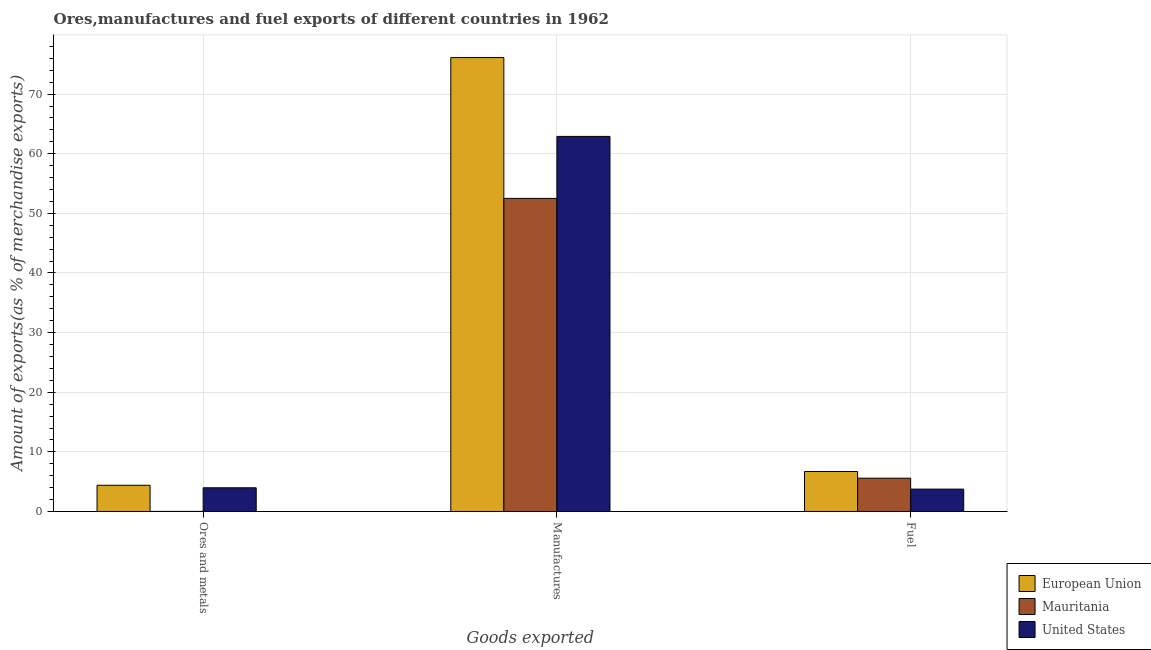How many different coloured bars are there?
Give a very brief answer. 3. How many groups of bars are there?
Make the answer very short. 3. Are the number of bars on each tick of the X-axis equal?
Your answer should be compact. Yes. What is the label of the 1st group of bars from the left?
Provide a succinct answer. Ores and metals. What is the percentage of manufactures exports in European Union?
Your answer should be very brief. 76.13. Across all countries, what is the maximum percentage of fuel exports?
Give a very brief answer. 6.71. Across all countries, what is the minimum percentage of fuel exports?
Your answer should be compact. 3.75. What is the total percentage of manufactures exports in the graph?
Offer a very short reply. 191.56. What is the difference between the percentage of manufactures exports in United States and that in European Union?
Ensure brevity in your answer.  -13.22. What is the difference between the percentage of fuel exports in European Union and the percentage of manufactures exports in United States?
Offer a very short reply. -56.21. What is the average percentage of ores and metals exports per country?
Provide a succinct answer. 2.79. What is the difference between the percentage of fuel exports and percentage of manufactures exports in European Union?
Ensure brevity in your answer.  -69.43. What is the ratio of the percentage of ores and metals exports in European Union to that in United States?
Give a very brief answer. 1.11. Is the difference between the percentage of manufactures exports in Mauritania and United States greater than the difference between the percentage of ores and metals exports in Mauritania and United States?
Make the answer very short. No. What is the difference between the highest and the second highest percentage of ores and metals exports?
Give a very brief answer. 0.42. What is the difference between the highest and the lowest percentage of fuel exports?
Offer a terse response. 2.95. Is the sum of the percentage of fuel exports in European Union and United States greater than the maximum percentage of manufactures exports across all countries?
Offer a terse response. No. Is it the case that in every country, the sum of the percentage of ores and metals exports and percentage of manufactures exports is greater than the percentage of fuel exports?
Offer a terse response. Yes. How many bars are there?
Provide a short and direct response. 9. How many countries are there in the graph?
Give a very brief answer. 3. Are the values on the major ticks of Y-axis written in scientific E-notation?
Make the answer very short. No. Where does the legend appear in the graph?
Offer a very short reply. Bottom right. What is the title of the graph?
Your answer should be compact. Ores,manufactures and fuel exports of different countries in 1962. What is the label or title of the X-axis?
Your answer should be very brief. Goods exported. What is the label or title of the Y-axis?
Ensure brevity in your answer.  Amount of exports(as % of merchandise exports). What is the Amount of exports(as % of merchandise exports) of European Union in Ores and metals?
Ensure brevity in your answer.  4.4. What is the Amount of exports(as % of merchandise exports) in Mauritania in Ores and metals?
Offer a terse response. 0.01. What is the Amount of exports(as % of merchandise exports) of United States in Ores and metals?
Ensure brevity in your answer.  3.97. What is the Amount of exports(as % of merchandise exports) in European Union in Manufactures?
Your answer should be very brief. 76.13. What is the Amount of exports(as % of merchandise exports) of Mauritania in Manufactures?
Offer a very short reply. 52.51. What is the Amount of exports(as % of merchandise exports) in United States in Manufactures?
Provide a short and direct response. 62.91. What is the Amount of exports(as % of merchandise exports) of European Union in Fuel?
Offer a terse response. 6.71. What is the Amount of exports(as % of merchandise exports) of Mauritania in Fuel?
Your answer should be very brief. 5.58. What is the Amount of exports(as % of merchandise exports) of United States in Fuel?
Your answer should be compact. 3.75. Across all Goods exported, what is the maximum Amount of exports(as % of merchandise exports) of European Union?
Your response must be concise. 76.13. Across all Goods exported, what is the maximum Amount of exports(as % of merchandise exports) of Mauritania?
Give a very brief answer. 52.51. Across all Goods exported, what is the maximum Amount of exports(as % of merchandise exports) in United States?
Your answer should be compact. 62.91. Across all Goods exported, what is the minimum Amount of exports(as % of merchandise exports) in European Union?
Your answer should be very brief. 4.4. Across all Goods exported, what is the minimum Amount of exports(as % of merchandise exports) of Mauritania?
Offer a terse response. 0.01. Across all Goods exported, what is the minimum Amount of exports(as % of merchandise exports) of United States?
Offer a very short reply. 3.75. What is the total Amount of exports(as % of merchandise exports) in European Union in the graph?
Provide a short and direct response. 87.24. What is the total Amount of exports(as % of merchandise exports) in Mauritania in the graph?
Your answer should be very brief. 58.11. What is the total Amount of exports(as % of merchandise exports) in United States in the graph?
Your response must be concise. 70.64. What is the difference between the Amount of exports(as % of merchandise exports) in European Union in Ores and metals and that in Manufactures?
Your answer should be compact. -71.74. What is the difference between the Amount of exports(as % of merchandise exports) in Mauritania in Ores and metals and that in Manufactures?
Keep it short and to the point. -52.5. What is the difference between the Amount of exports(as % of merchandise exports) of United States in Ores and metals and that in Manufactures?
Provide a short and direct response. -58.94. What is the difference between the Amount of exports(as % of merchandise exports) in European Union in Ores and metals and that in Fuel?
Give a very brief answer. -2.31. What is the difference between the Amount of exports(as % of merchandise exports) of Mauritania in Ores and metals and that in Fuel?
Give a very brief answer. -5.57. What is the difference between the Amount of exports(as % of merchandise exports) in United States in Ores and metals and that in Fuel?
Your response must be concise. 0.22. What is the difference between the Amount of exports(as % of merchandise exports) of European Union in Manufactures and that in Fuel?
Provide a succinct answer. 69.43. What is the difference between the Amount of exports(as % of merchandise exports) of Mauritania in Manufactures and that in Fuel?
Offer a very short reply. 46.93. What is the difference between the Amount of exports(as % of merchandise exports) of United States in Manufactures and that in Fuel?
Offer a terse response. 59.16. What is the difference between the Amount of exports(as % of merchandise exports) of European Union in Ores and metals and the Amount of exports(as % of merchandise exports) of Mauritania in Manufactures?
Offer a terse response. -48.12. What is the difference between the Amount of exports(as % of merchandise exports) of European Union in Ores and metals and the Amount of exports(as % of merchandise exports) of United States in Manufactures?
Your response must be concise. -58.52. What is the difference between the Amount of exports(as % of merchandise exports) in Mauritania in Ores and metals and the Amount of exports(as % of merchandise exports) in United States in Manufactures?
Ensure brevity in your answer.  -62.9. What is the difference between the Amount of exports(as % of merchandise exports) in European Union in Ores and metals and the Amount of exports(as % of merchandise exports) in Mauritania in Fuel?
Give a very brief answer. -1.19. What is the difference between the Amount of exports(as % of merchandise exports) in European Union in Ores and metals and the Amount of exports(as % of merchandise exports) in United States in Fuel?
Give a very brief answer. 0.64. What is the difference between the Amount of exports(as % of merchandise exports) of Mauritania in Ores and metals and the Amount of exports(as % of merchandise exports) of United States in Fuel?
Your answer should be very brief. -3.74. What is the difference between the Amount of exports(as % of merchandise exports) of European Union in Manufactures and the Amount of exports(as % of merchandise exports) of Mauritania in Fuel?
Provide a short and direct response. 70.55. What is the difference between the Amount of exports(as % of merchandise exports) in European Union in Manufactures and the Amount of exports(as % of merchandise exports) in United States in Fuel?
Offer a terse response. 72.38. What is the difference between the Amount of exports(as % of merchandise exports) of Mauritania in Manufactures and the Amount of exports(as % of merchandise exports) of United States in Fuel?
Make the answer very short. 48.76. What is the average Amount of exports(as % of merchandise exports) in European Union per Goods exported?
Provide a succinct answer. 29.08. What is the average Amount of exports(as % of merchandise exports) in Mauritania per Goods exported?
Offer a terse response. 19.37. What is the average Amount of exports(as % of merchandise exports) in United States per Goods exported?
Offer a terse response. 23.55. What is the difference between the Amount of exports(as % of merchandise exports) in European Union and Amount of exports(as % of merchandise exports) in Mauritania in Ores and metals?
Provide a short and direct response. 4.38. What is the difference between the Amount of exports(as % of merchandise exports) in European Union and Amount of exports(as % of merchandise exports) in United States in Ores and metals?
Provide a short and direct response. 0.42. What is the difference between the Amount of exports(as % of merchandise exports) in Mauritania and Amount of exports(as % of merchandise exports) in United States in Ores and metals?
Give a very brief answer. -3.96. What is the difference between the Amount of exports(as % of merchandise exports) in European Union and Amount of exports(as % of merchandise exports) in Mauritania in Manufactures?
Provide a short and direct response. 23.62. What is the difference between the Amount of exports(as % of merchandise exports) of European Union and Amount of exports(as % of merchandise exports) of United States in Manufactures?
Offer a terse response. 13.22. What is the difference between the Amount of exports(as % of merchandise exports) in Mauritania and Amount of exports(as % of merchandise exports) in United States in Manufactures?
Your answer should be compact. -10.4. What is the difference between the Amount of exports(as % of merchandise exports) in European Union and Amount of exports(as % of merchandise exports) in Mauritania in Fuel?
Keep it short and to the point. 1.12. What is the difference between the Amount of exports(as % of merchandise exports) in European Union and Amount of exports(as % of merchandise exports) in United States in Fuel?
Ensure brevity in your answer.  2.95. What is the difference between the Amount of exports(as % of merchandise exports) in Mauritania and Amount of exports(as % of merchandise exports) in United States in Fuel?
Offer a terse response. 1.83. What is the ratio of the Amount of exports(as % of merchandise exports) in European Union in Ores and metals to that in Manufactures?
Your response must be concise. 0.06. What is the ratio of the Amount of exports(as % of merchandise exports) of Mauritania in Ores and metals to that in Manufactures?
Keep it short and to the point. 0. What is the ratio of the Amount of exports(as % of merchandise exports) in United States in Ores and metals to that in Manufactures?
Provide a succinct answer. 0.06. What is the ratio of the Amount of exports(as % of merchandise exports) in European Union in Ores and metals to that in Fuel?
Ensure brevity in your answer.  0.66. What is the ratio of the Amount of exports(as % of merchandise exports) of Mauritania in Ores and metals to that in Fuel?
Ensure brevity in your answer.  0. What is the ratio of the Amount of exports(as % of merchandise exports) in United States in Ores and metals to that in Fuel?
Make the answer very short. 1.06. What is the ratio of the Amount of exports(as % of merchandise exports) of European Union in Manufactures to that in Fuel?
Keep it short and to the point. 11.35. What is the ratio of the Amount of exports(as % of merchandise exports) of Mauritania in Manufactures to that in Fuel?
Your response must be concise. 9.41. What is the ratio of the Amount of exports(as % of merchandise exports) of United States in Manufactures to that in Fuel?
Keep it short and to the point. 16.77. What is the difference between the highest and the second highest Amount of exports(as % of merchandise exports) in European Union?
Offer a terse response. 69.43. What is the difference between the highest and the second highest Amount of exports(as % of merchandise exports) of Mauritania?
Give a very brief answer. 46.93. What is the difference between the highest and the second highest Amount of exports(as % of merchandise exports) in United States?
Make the answer very short. 58.94. What is the difference between the highest and the lowest Amount of exports(as % of merchandise exports) in European Union?
Offer a very short reply. 71.74. What is the difference between the highest and the lowest Amount of exports(as % of merchandise exports) in Mauritania?
Your answer should be very brief. 52.5. What is the difference between the highest and the lowest Amount of exports(as % of merchandise exports) in United States?
Provide a short and direct response. 59.16. 